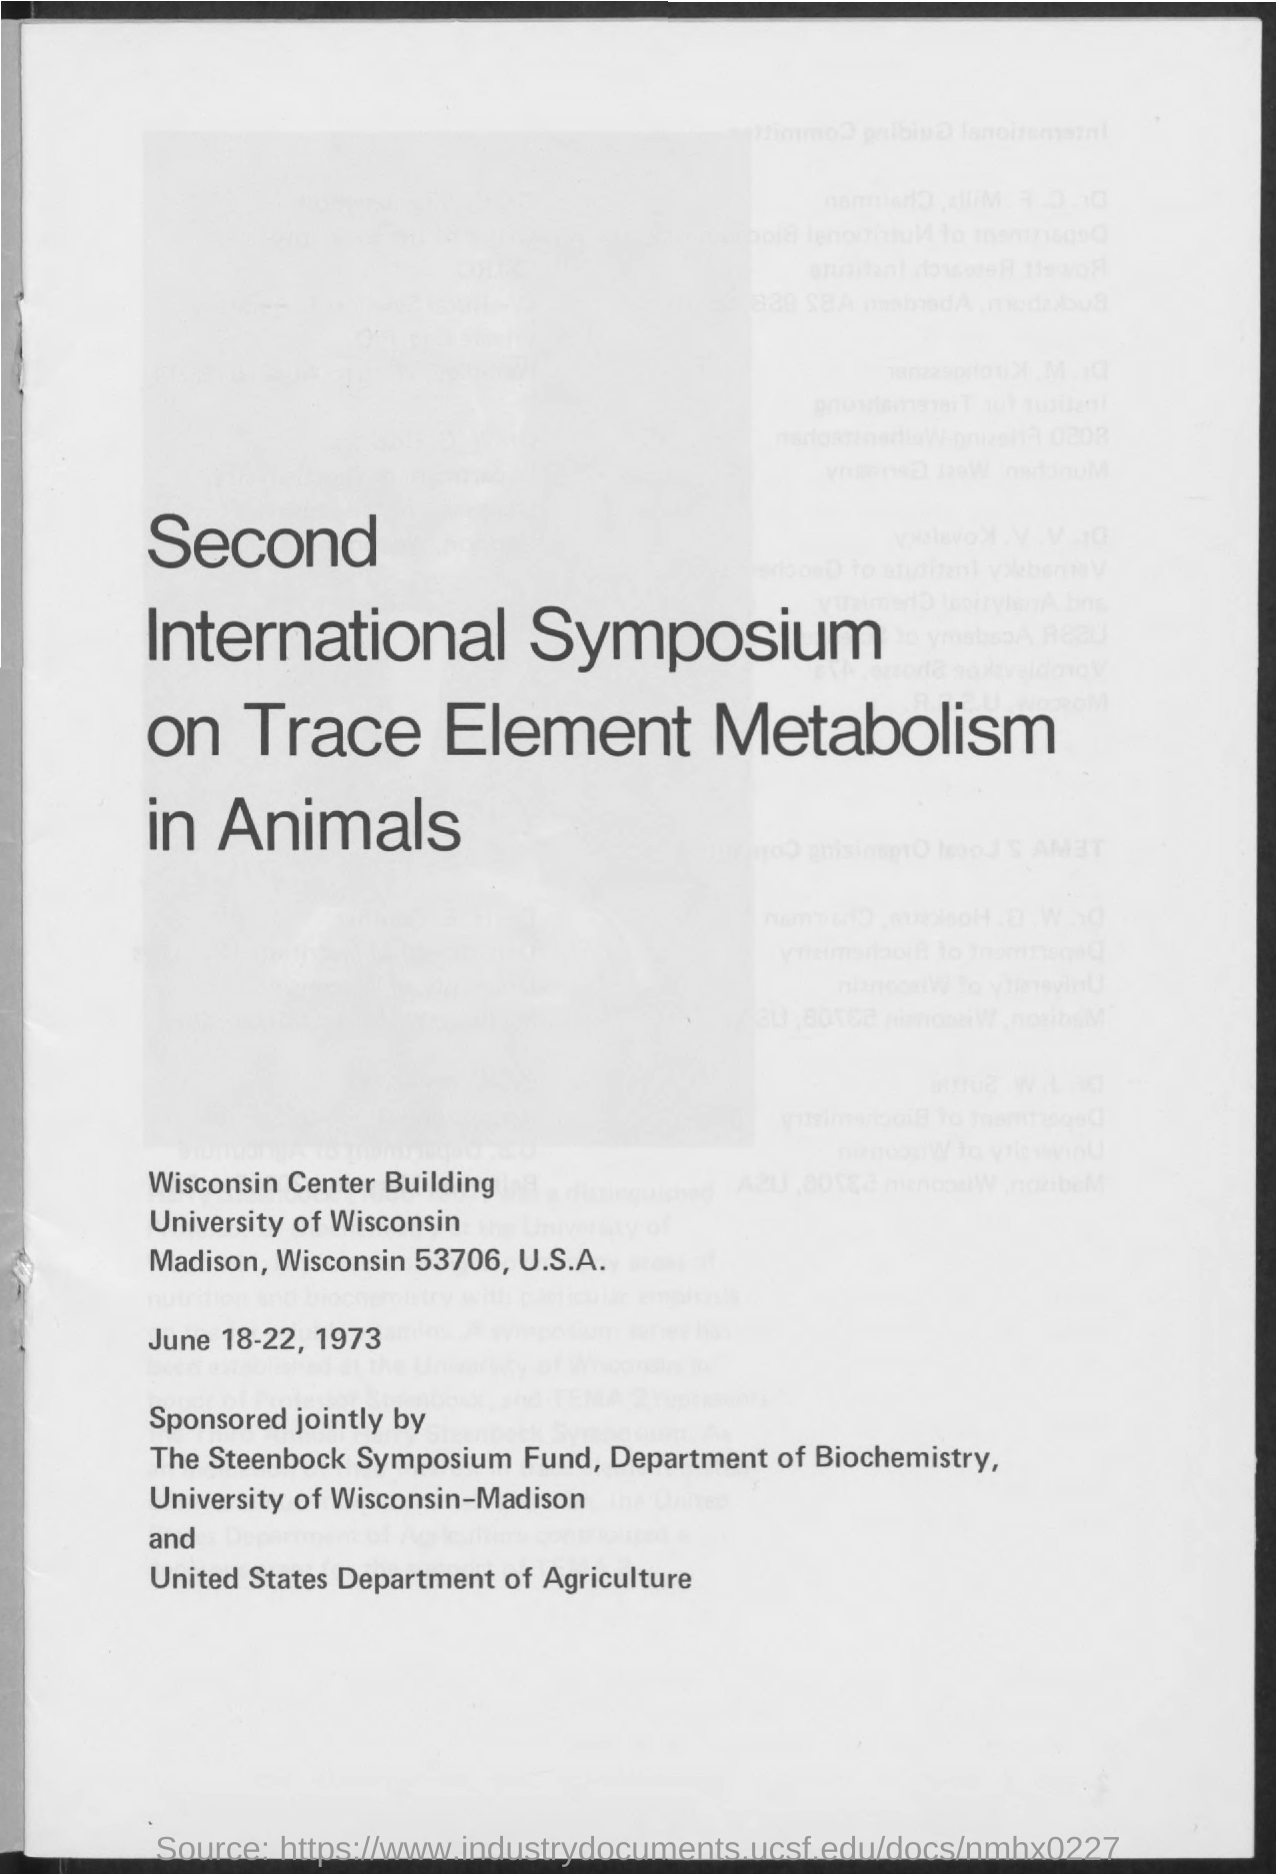When was the Second International Symposium on Trace Element Metabolism in Animals held?
Offer a terse response. June 18-22, 1973. 